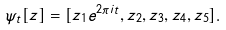<formula> <loc_0><loc_0><loc_500><loc_500>\psi _ { t } [ z ] = [ z _ { 1 } e ^ { 2 \pi i t } , z _ { 2 } , z _ { 3 } , z _ { 4 } , z _ { 5 } ] .</formula> 